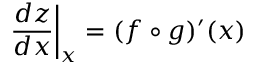<formula> <loc_0><loc_0><loc_500><loc_500>{ \frac { d z } { d x } } \right | _ { x } = ( f \circ g ) ^ { \prime } ( x )</formula> 